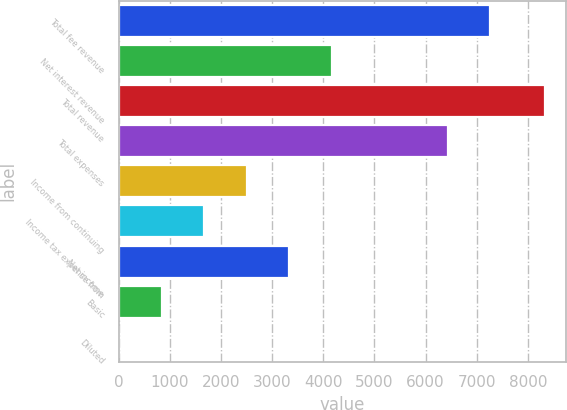Convert chart. <chart><loc_0><loc_0><loc_500><loc_500><bar_chart><fcel>Total fee revenue<fcel>Net interest revenue<fcel>Total revenue<fcel>Total expenses<fcel>Income from continuing<fcel>Income tax expense from<fcel>Net income<fcel>Basic<fcel>Diluted<nl><fcel>7266.26<fcel>4169.72<fcel>8336<fcel>6433<fcel>2503.22<fcel>1669.97<fcel>3336.47<fcel>836.71<fcel>3.45<nl></chart> 